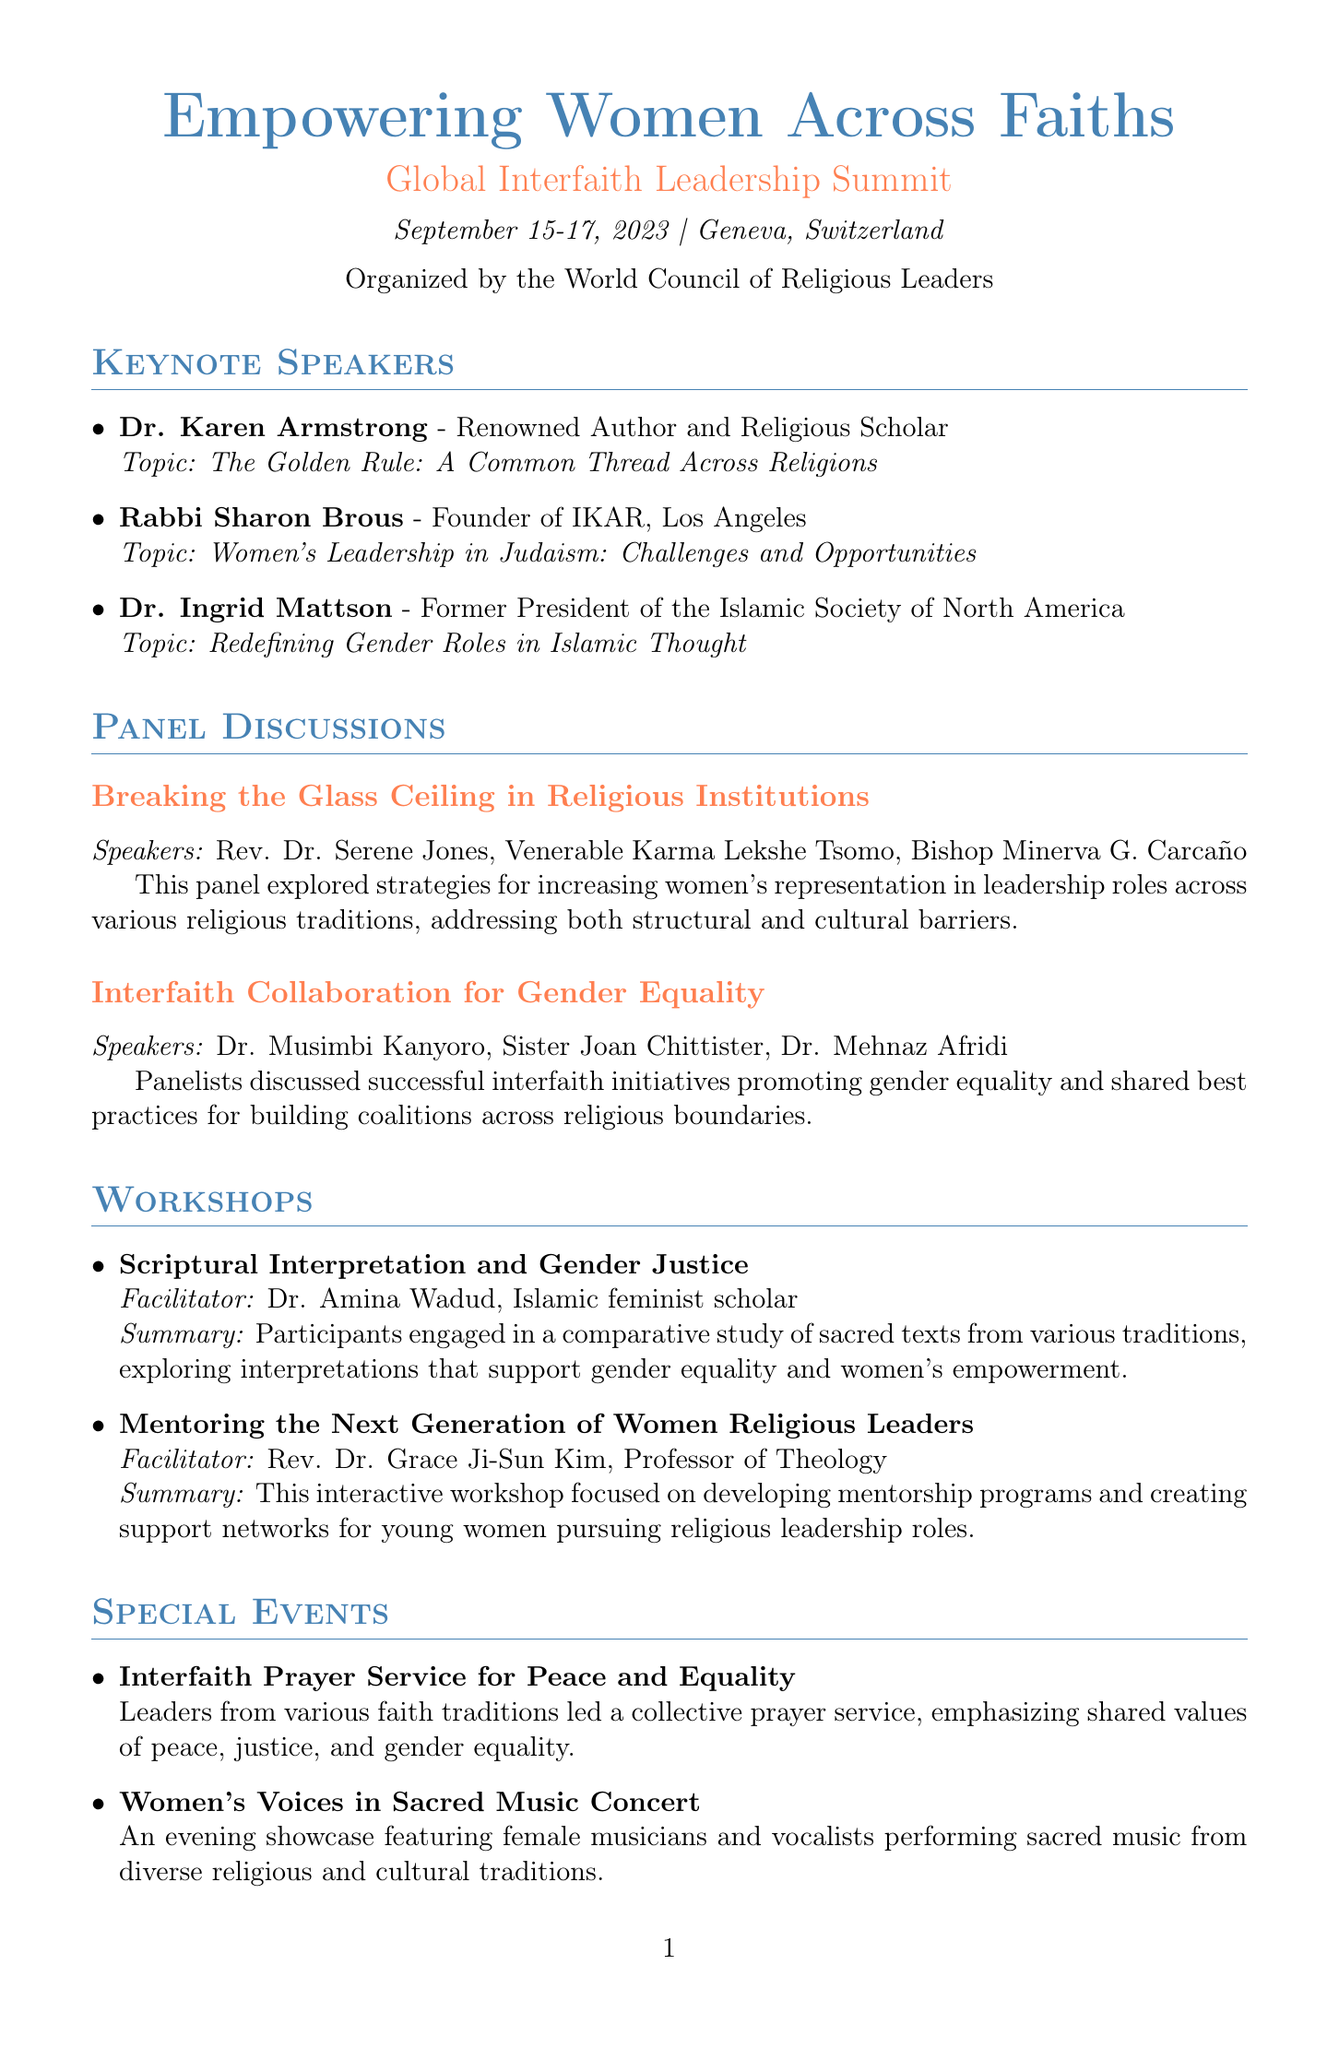What is the title of the conference? The title of the conference is explicitly mentioned in the document.
Answer: Empowering Women Across Faiths: Global Interfaith Leadership Summit Who organized the conference? The organizer is specified in the document.
Answer: World Council of Religious Leaders What is the date of the conference? The date is clearly stated in the document.
Answer: September 15-17, 2023 How many keynote speakers were there? The number of keynote speakers can be counted from the list in the document.
Answer: 3 Who is the facilitator of the workshop on mentoring? The document lists the facilitator for each workshop.
Answer: Rev. Dr. Grace Ji-Sun Kim What was the topic of Dr. Ingrid Mattson’s keynote address? The topic is provided in the speaker list section.
Answer: Redefining Gender Roles in Islamic Thought What outcome involves forming a network? The outcomes list provides information on specific initiatives resulting from the conference.
Answer: Formation of a Global Interfaith Women's Leadership Network Which speaker discussed challenges and opportunities in Judaism? The document mentions the specific speaker tackling this topic.
Answer: Rabbi Sharon Brous What was the theme of the interfaith prayer service? The description of the event outlines its primary focus.
Answer: Peace and Equality 